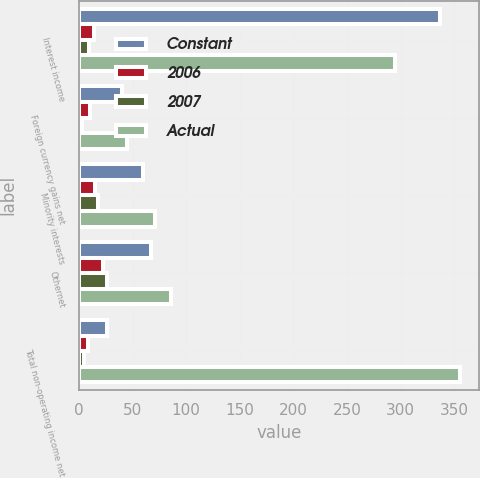<chart> <loc_0><loc_0><loc_500><loc_500><stacked_bar_chart><ecel><fcel>Interest income<fcel>Foreign currency gains net<fcel>Minority interests<fcel>Othernet<fcel>Total non-operating income net<nl><fcel>Constant<fcel>337<fcel>40<fcel>60<fcel>67<fcel>26<nl><fcel>2006<fcel>14<fcel>10<fcel>15<fcel>22<fcel>8<nl><fcel>2007<fcel>9<fcel>3<fcel>18<fcel>26<fcel>5<nl><fcel>Actual<fcel>295<fcel>45<fcel>71<fcel>86<fcel>355<nl></chart> 